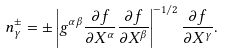Convert formula to latex. <formula><loc_0><loc_0><loc_500><loc_500>n _ { \gamma } ^ { \pm } = \pm \left | g ^ { \alpha \beta } \frac { \partial f } { \partial X ^ { \alpha } } \frac { \partial f } { \partial X ^ { \beta } } \right | ^ { - 1 / 2 } \frac { \partial f } { \partial X ^ { \gamma } } .</formula> 